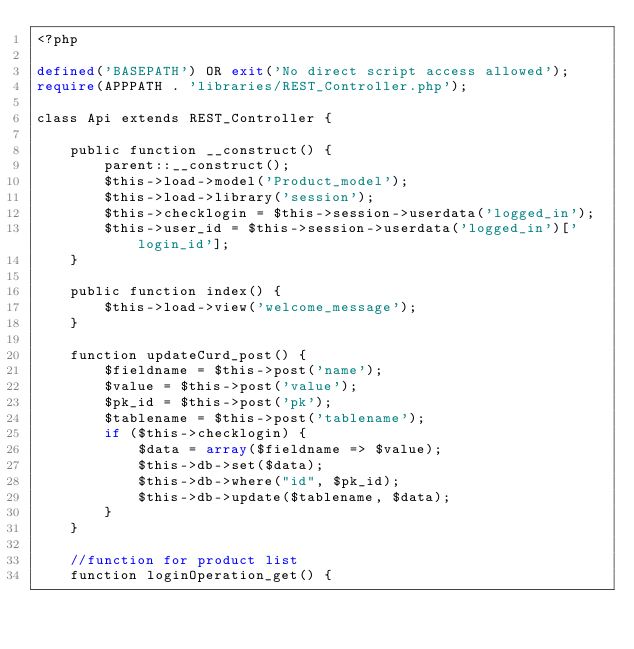<code> <loc_0><loc_0><loc_500><loc_500><_PHP_><?php

defined('BASEPATH') OR exit('No direct script access allowed');
require(APPPATH . 'libraries/REST_Controller.php');

class Api extends REST_Controller {

    public function __construct() {
        parent::__construct();
        $this->load->model('Product_model');
        $this->load->library('session');
        $this->checklogin = $this->session->userdata('logged_in');
        $this->user_id = $this->session->userdata('logged_in')['login_id'];
    }

    public function index() {
        $this->load->view('welcome_message');
    }

    function updateCurd_post() {
        $fieldname = $this->post('name');
        $value = $this->post('value');
        $pk_id = $this->post('pk');
        $tablename = $this->post('tablename');
        if ($this->checklogin) {
            $data = array($fieldname => $value);
            $this->db->set($data);
            $this->db->where("id", $pk_id);
            $this->db->update($tablename, $data);
        }
    }

    //function for product list
    function loginOperation_get() {</code> 